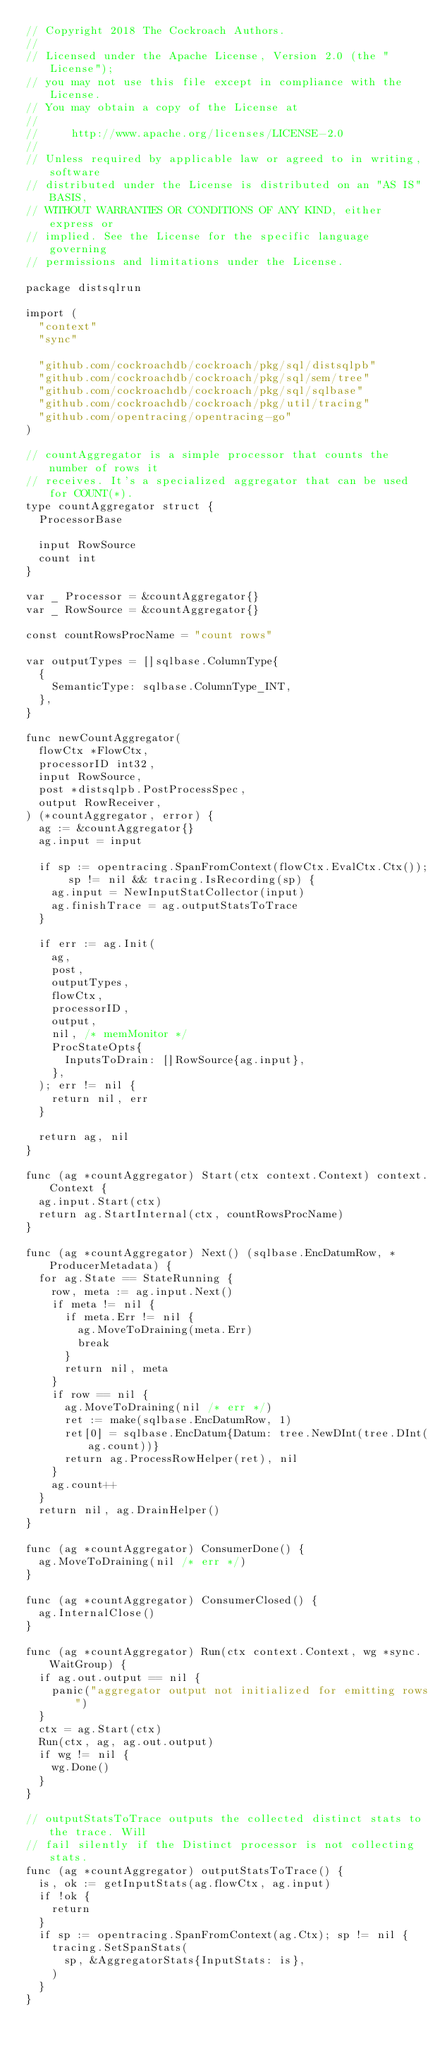<code> <loc_0><loc_0><loc_500><loc_500><_Go_>// Copyright 2018 The Cockroach Authors.
//
// Licensed under the Apache License, Version 2.0 (the "License");
// you may not use this file except in compliance with the License.
// You may obtain a copy of the License at
//
//     http://www.apache.org/licenses/LICENSE-2.0
//
// Unless required by applicable law or agreed to in writing, software
// distributed under the License is distributed on an "AS IS" BASIS,
// WITHOUT WARRANTIES OR CONDITIONS OF ANY KIND, either express or
// implied. See the License for the specific language governing
// permissions and limitations under the License.

package distsqlrun

import (
	"context"
	"sync"

	"github.com/cockroachdb/cockroach/pkg/sql/distsqlpb"
	"github.com/cockroachdb/cockroach/pkg/sql/sem/tree"
	"github.com/cockroachdb/cockroach/pkg/sql/sqlbase"
	"github.com/cockroachdb/cockroach/pkg/util/tracing"
	"github.com/opentracing/opentracing-go"
)

// countAggregator is a simple processor that counts the number of rows it
// receives. It's a specialized aggregator that can be used for COUNT(*).
type countAggregator struct {
	ProcessorBase

	input RowSource
	count int
}

var _ Processor = &countAggregator{}
var _ RowSource = &countAggregator{}

const countRowsProcName = "count rows"

var outputTypes = []sqlbase.ColumnType{
	{
		SemanticType: sqlbase.ColumnType_INT,
	},
}

func newCountAggregator(
	flowCtx *FlowCtx,
	processorID int32,
	input RowSource,
	post *distsqlpb.PostProcessSpec,
	output RowReceiver,
) (*countAggregator, error) {
	ag := &countAggregator{}
	ag.input = input

	if sp := opentracing.SpanFromContext(flowCtx.EvalCtx.Ctx()); sp != nil && tracing.IsRecording(sp) {
		ag.input = NewInputStatCollector(input)
		ag.finishTrace = ag.outputStatsToTrace
	}

	if err := ag.Init(
		ag,
		post,
		outputTypes,
		flowCtx,
		processorID,
		output,
		nil, /* memMonitor */
		ProcStateOpts{
			InputsToDrain: []RowSource{ag.input},
		},
	); err != nil {
		return nil, err
	}

	return ag, nil
}

func (ag *countAggregator) Start(ctx context.Context) context.Context {
	ag.input.Start(ctx)
	return ag.StartInternal(ctx, countRowsProcName)
}

func (ag *countAggregator) Next() (sqlbase.EncDatumRow, *ProducerMetadata) {
	for ag.State == StateRunning {
		row, meta := ag.input.Next()
		if meta != nil {
			if meta.Err != nil {
				ag.MoveToDraining(meta.Err)
				break
			}
			return nil, meta
		}
		if row == nil {
			ag.MoveToDraining(nil /* err */)
			ret := make(sqlbase.EncDatumRow, 1)
			ret[0] = sqlbase.EncDatum{Datum: tree.NewDInt(tree.DInt(ag.count))}
			return ag.ProcessRowHelper(ret), nil
		}
		ag.count++
	}
	return nil, ag.DrainHelper()
}

func (ag *countAggregator) ConsumerDone() {
	ag.MoveToDraining(nil /* err */)
}

func (ag *countAggregator) ConsumerClosed() {
	ag.InternalClose()
}

func (ag *countAggregator) Run(ctx context.Context, wg *sync.WaitGroup) {
	if ag.out.output == nil {
		panic("aggregator output not initialized for emitting rows")
	}
	ctx = ag.Start(ctx)
	Run(ctx, ag, ag.out.output)
	if wg != nil {
		wg.Done()
	}
}

// outputStatsToTrace outputs the collected distinct stats to the trace. Will
// fail silently if the Distinct processor is not collecting stats.
func (ag *countAggregator) outputStatsToTrace() {
	is, ok := getInputStats(ag.flowCtx, ag.input)
	if !ok {
		return
	}
	if sp := opentracing.SpanFromContext(ag.Ctx); sp != nil {
		tracing.SetSpanStats(
			sp, &AggregatorStats{InputStats: is},
		)
	}
}
</code> 